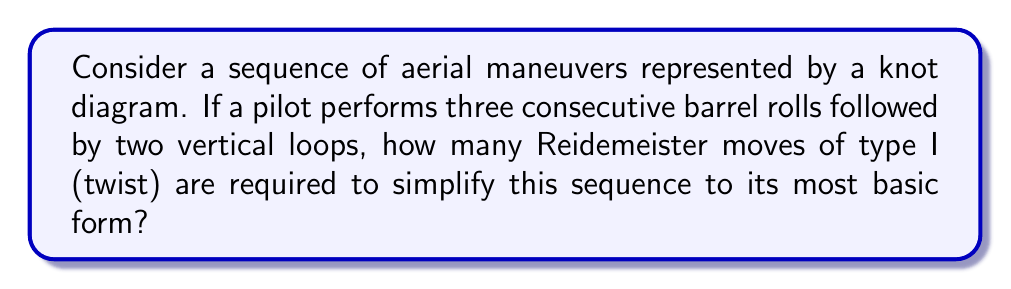Provide a solution to this math problem. Let's approach this step-by-step:

1) First, we need to understand what each maneuver represents in knot theory:
   - A barrel roll creates a full twist in the knot diagram.
   - A vertical loop creates a simple closed curve.

2) The sequence of maneuvers can be represented as:
   $$(T_1 \circ T_2 \circ T_3) \circ (L_1 \circ L_2)$$
   where $T_i$ represents a twist (barrel roll) and $L_j$ represents a loop.

3) In knot theory, consecutive twists in the same direction can be combined. Three consecutive barrel rolls would create three full twists, which can be represented as a single triple twist.

4) The two vertical loops, being simple closed curves, don't contribute to the complexity of the knot in terms of Reidemeister moves.

5) Therefore, our simplified knot diagram essentially consists of a triple twist.

6) The Reidemeister move of type I (twist) is used to add or remove a twist in a knot diagram.

7) To simplify our triple twist to its most basic form (a straight line), we need to apply the type I Reidemeister move three times, once for each twist.

Therefore, three Reidemeister moves of type I are required to simplify this sequence to its most basic form.
Answer: 3 